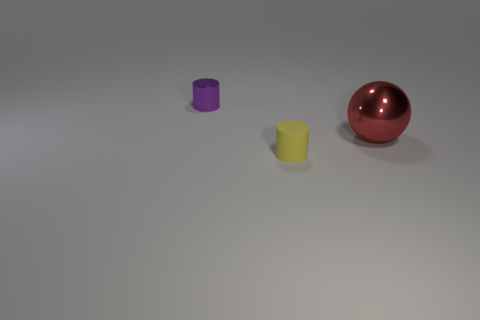Do the tiny cylinder behind the tiny yellow cylinder and the object that is right of the yellow rubber thing have the same material?
Provide a succinct answer. Yes. Are the large ball and the object that is to the left of the yellow rubber thing made of the same material?
Your answer should be very brief. Yes. What is the tiny yellow cylinder made of?
Provide a short and direct response. Rubber. What material is the tiny object that is to the right of the tiny cylinder that is to the left of the tiny cylinder that is on the right side of the tiny shiny thing?
Your response must be concise. Rubber. There is a cylinder that is in front of the shiny cylinder; is it the same size as the thing that is behind the sphere?
Your response must be concise. Yes. What number of other things are made of the same material as the big red thing?
Your answer should be compact. 1. What number of matte things are small cyan balls or purple objects?
Your answer should be compact. 0. Is the number of small yellow objects less than the number of large brown blocks?
Ensure brevity in your answer.  No. There is a rubber cylinder; does it have the same size as the purple thing that is to the left of the metal sphere?
Your response must be concise. Yes. Is there any other thing that is the same shape as the large red metal thing?
Provide a short and direct response. No. 